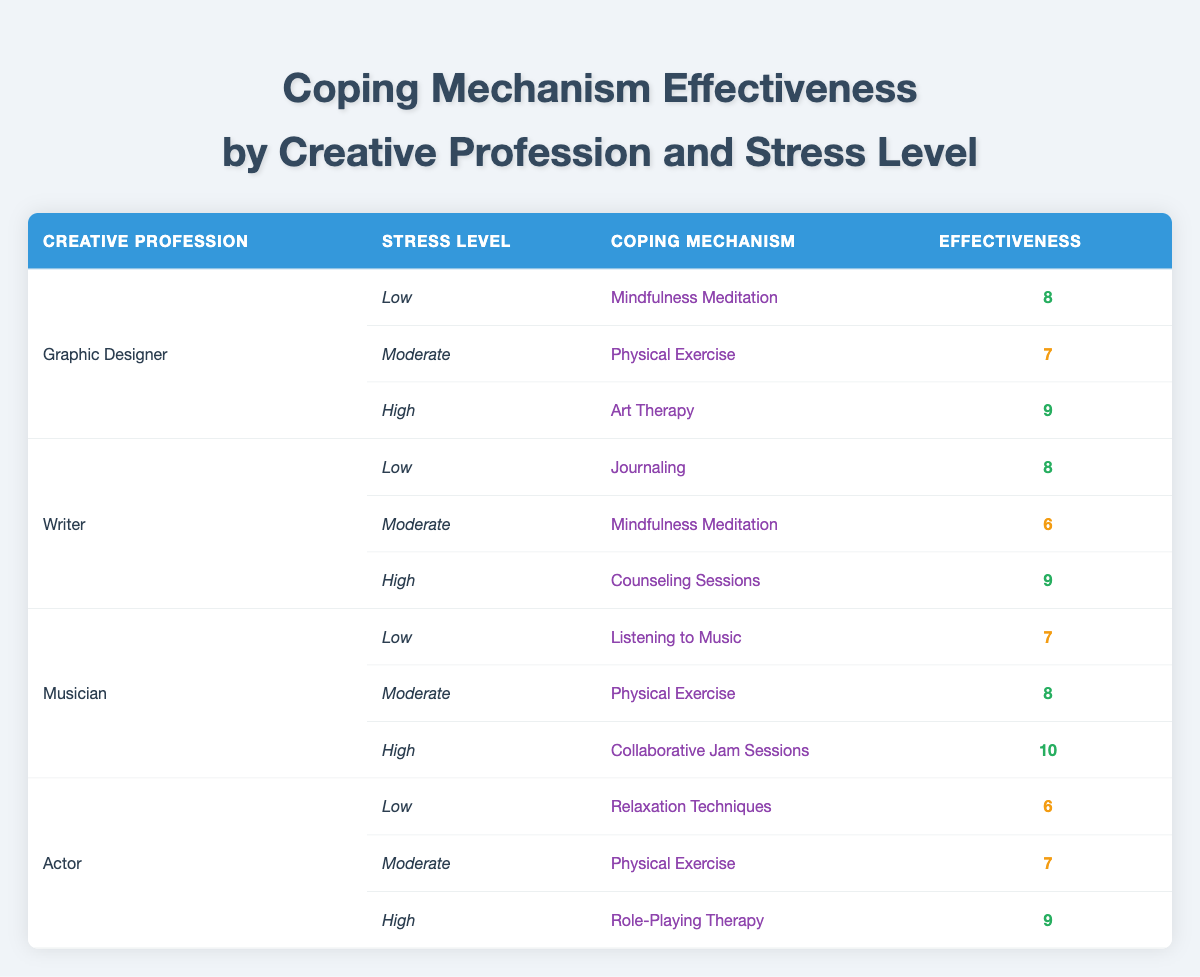What is the effectiveness of Physical Exercise for Graphic Designers at a Moderate stress level? In the table, we find the row corresponding to "Graphic Designer" and "Moderate" stress level. The Coping Mechanism listed is "Physical Exercise," and the Effectiveness is 7.
Answer: 7 Which coping mechanism has the highest effectiveness for Musicians at High stress levels? The row for Musicians with "High" stress level shows "Collaborative Jam Sessions" as the coping mechanism, which has an effectiveness rating of 10.
Answer: 10 Is Journaling effective for Writers at Low stress levels? Looking at the table, "Journaling" is listed for Writers at Low stress levels with an effectiveness rating of 8, indicating that it is indeed effective.
Answer: Yes What is the average effectiveness of stress coping mechanisms among Actors? We have three effectiveness ratings for Actors at different stress levels: 6 (Low), 7 (Moderate), and 9 (High). To find the average, we sum these values (6 + 7 + 9 = 22) and divide by the number of coping mechanisms (3), resulting in an average of 22 / 3 = 7.33.
Answer: 7.33 Are there any coping mechanisms that are the same for Writers and Graphic Designers at the Moderate stress level? For Graphic Designers, the coping mechanism for Moderate stress is "Physical Exercise." For Writers, it is "Mindfulness Meditation." Since these coping mechanisms are different, the answer is no.
Answer: No What is the difference in effectiveness between the highest and lowest-rated coping mechanisms for Actors? For Actors, the highest effectiveness is 9 (Role-Playing Therapy), and the lowest is 6 (Relaxation Techniques). The difference is calculated by subtracting the lowest from the highest (9 - 6 = 3).
Answer: 3 Which coping mechanism for Musicians at Low stress levels is more effective than the corresponding mechanism for Actors? For Musicians at Low stress, the mechanism is "Listening to Music" with effectiveness 7. For Actors at Low stress, the mechanism is "Relaxation Techniques" with effectiveness 6. Since 7 > 6, it does indeed qualify as more effective.
Answer: Yes Is Physical Exercise equally effective for both Musicians at Moderate levels and Actors at Moderate levels? For Musicians at Moderate levels, the effectiveness of Physical Exercise is 8, while for Actors it is 7. Since 8 is not equal to 7, the answer is no.
Answer: No 